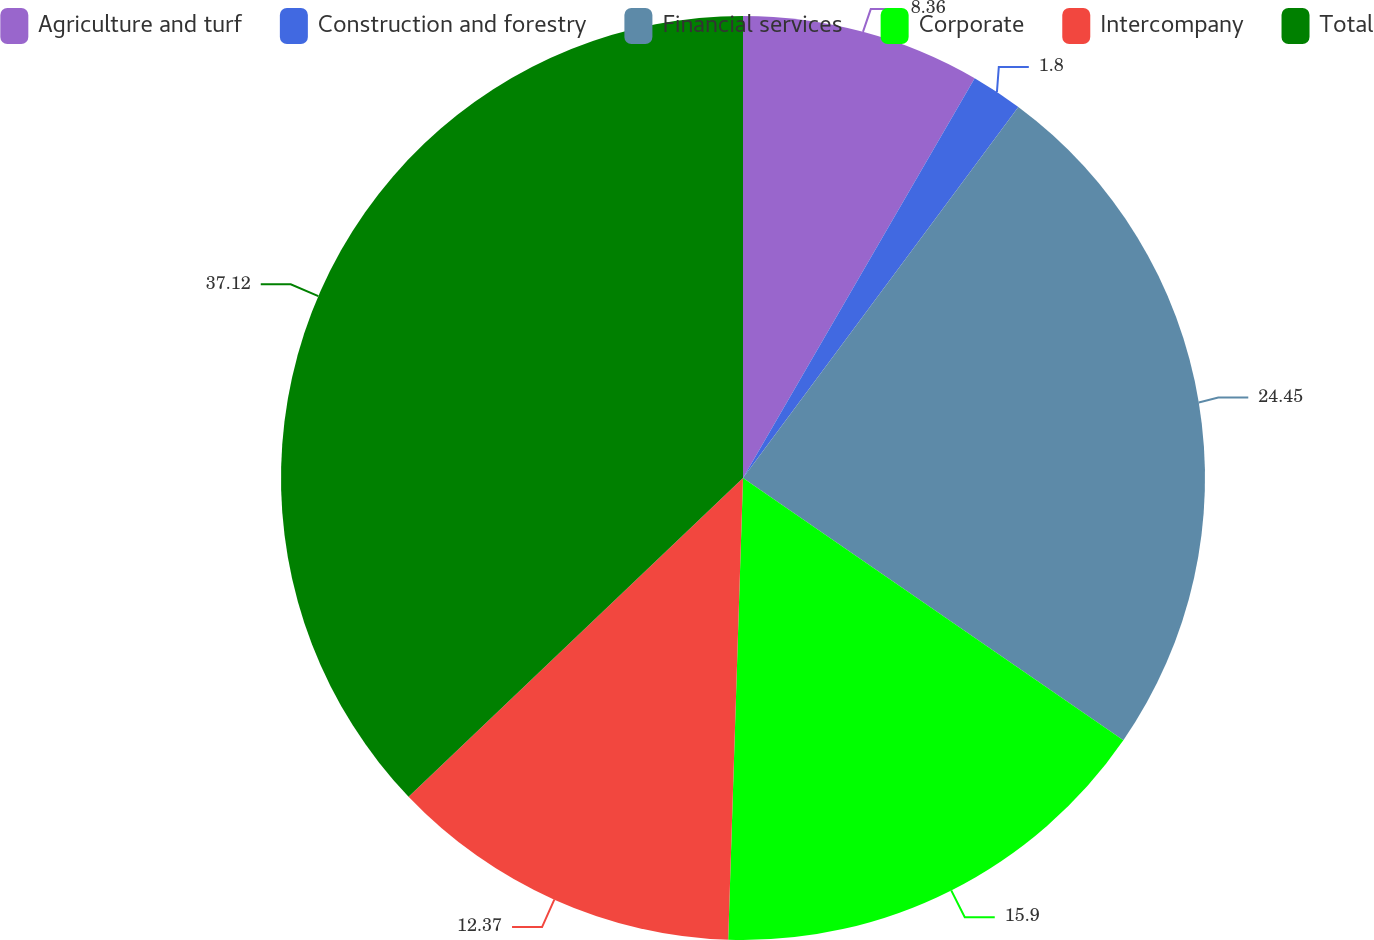<chart> <loc_0><loc_0><loc_500><loc_500><pie_chart><fcel>Agriculture and turf<fcel>Construction and forestry<fcel>Financial services<fcel>Corporate<fcel>Intercompany<fcel>Total<nl><fcel>8.36%<fcel>1.8%<fcel>24.44%<fcel>15.9%<fcel>12.37%<fcel>37.11%<nl></chart> 